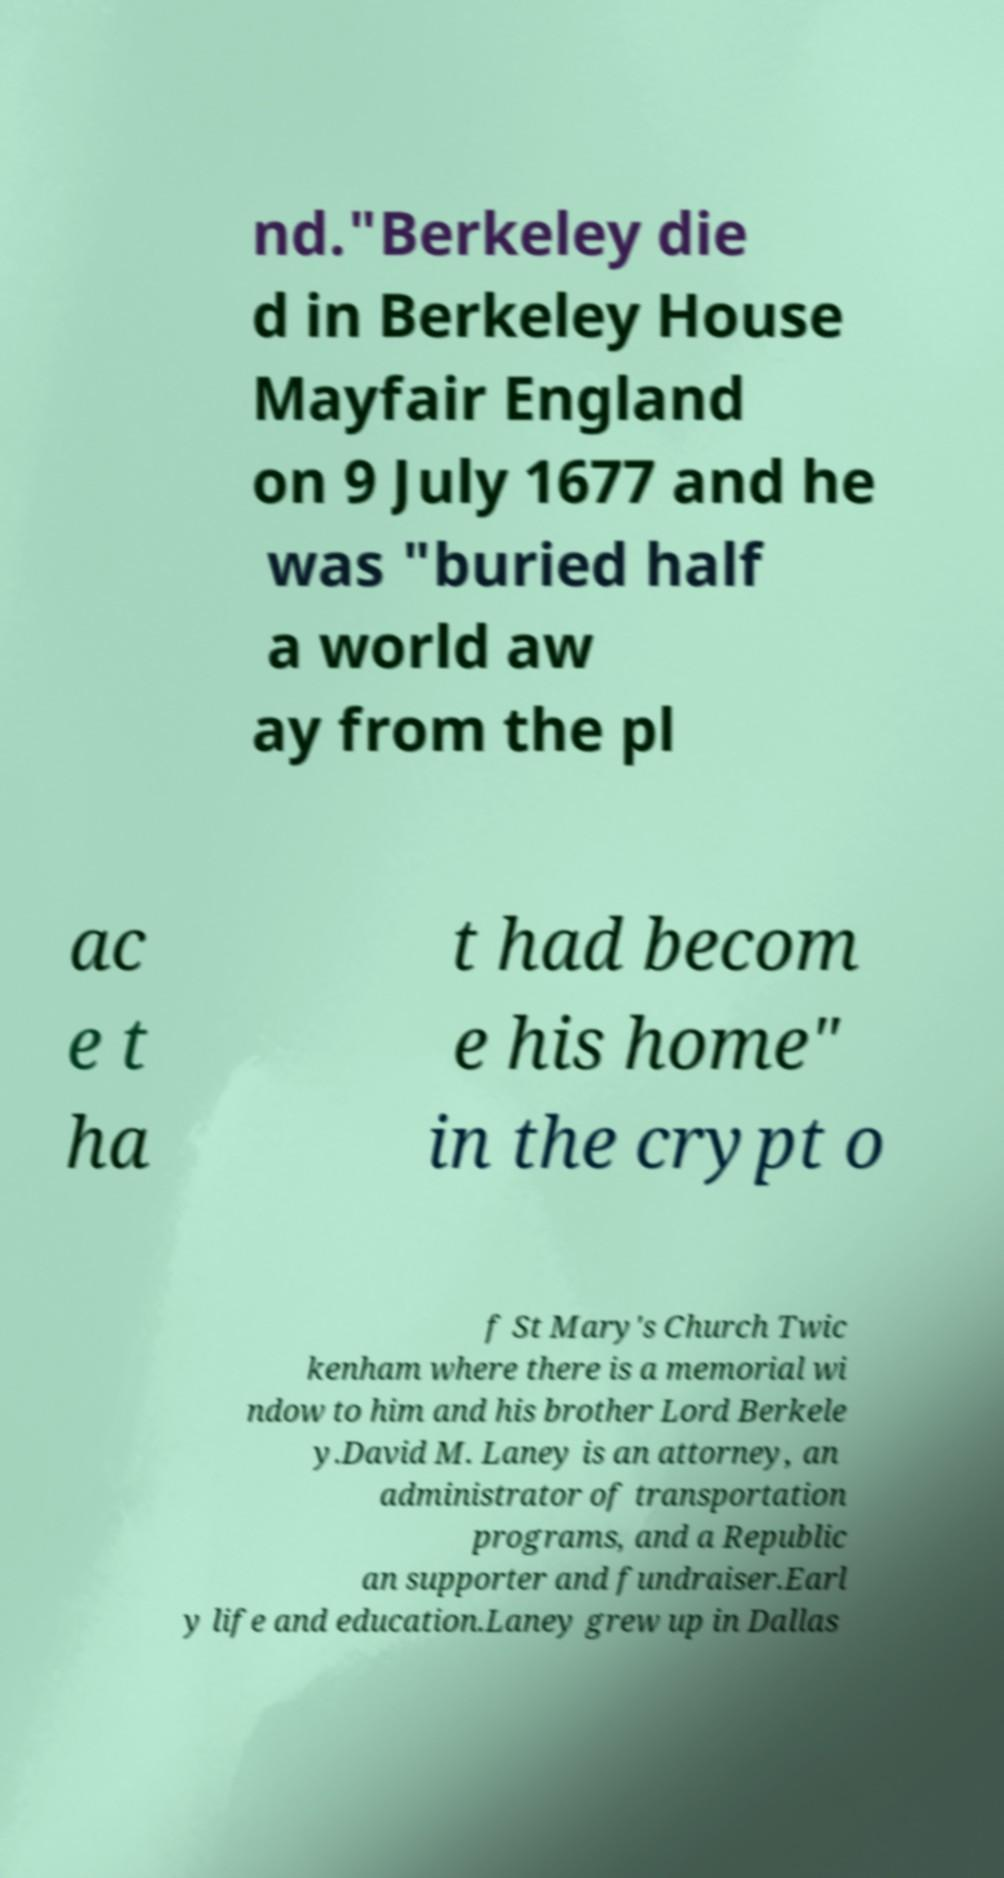For documentation purposes, I need the text within this image transcribed. Could you provide that? nd."Berkeley die d in Berkeley House Mayfair England on 9 July 1677 and he was "buried half a world aw ay from the pl ac e t ha t had becom e his home" in the crypt o f St Mary's Church Twic kenham where there is a memorial wi ndow to him and his brother Lord Berkele y.David M. Laney is an attorney, an administrator of transportation programs, and a Republic an supporter and fundraiser.Earl y life and education.Laney grew up in Dallas 